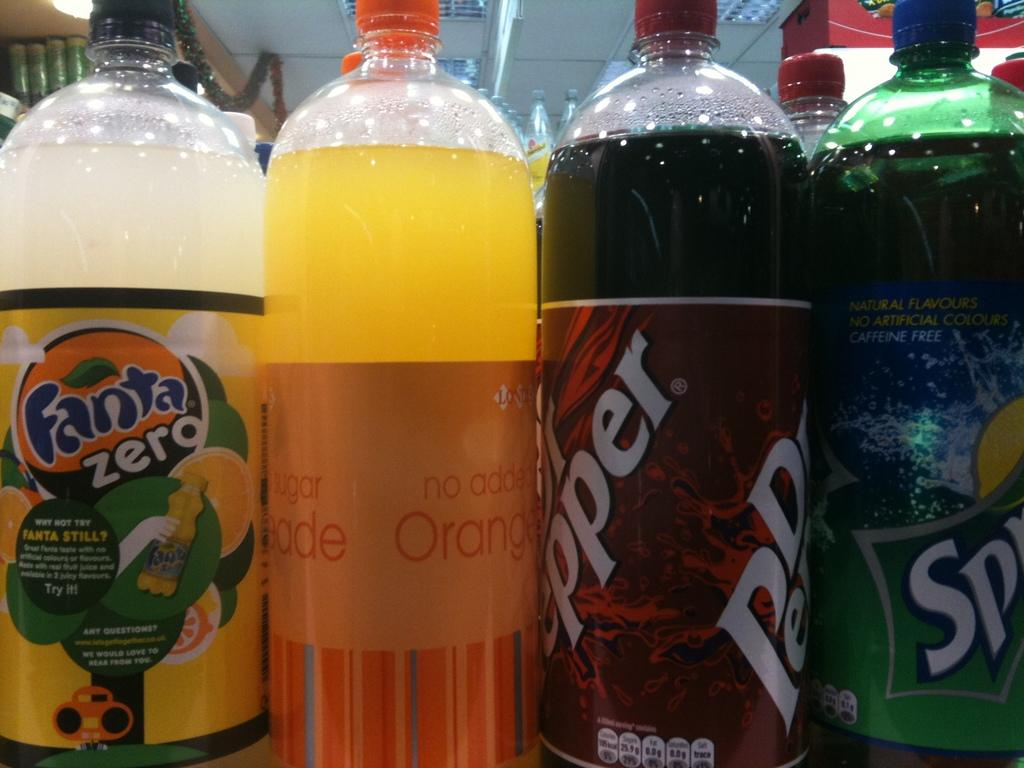What type of containers are present in the image? The image consists of bottles. What are the bottles containing? The bottles contain cool drinks. Can you name any specific cool drinks mentioned in the image? Yes, there are four specific cool drink bottles mentioned: "Sprite", "pepper", "no added orange", and "fanta". What reward is given to the beginner for using their elbow in the image? There is no reward, beginner, or elbow present in the image; it only consists of bottles containing cool drinks. 